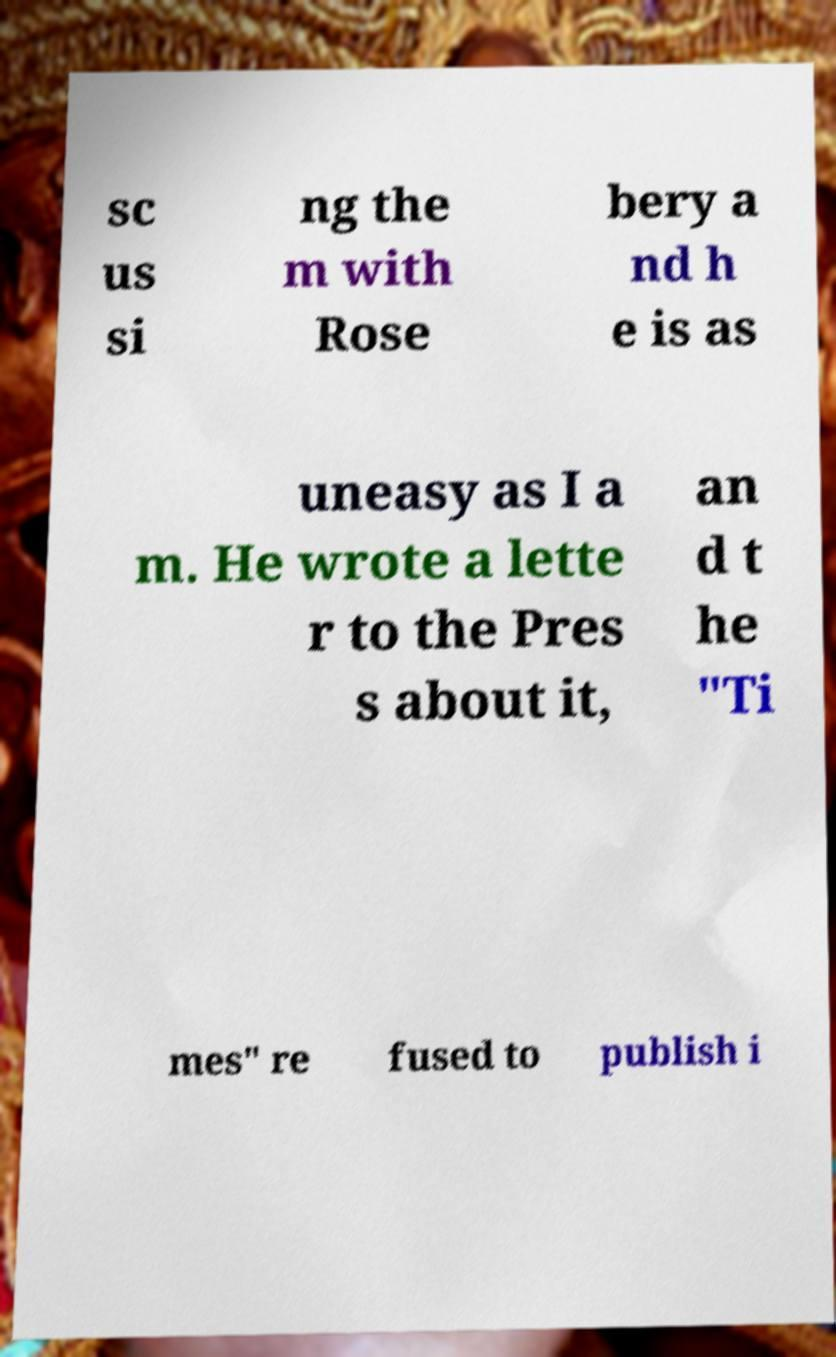There's text embedded in this image that I need extracted. Can you transcribe it verbatim? sc us si ng the m with Rose bery a nd h e is as uneasy as I a m. He wrote a lette r to the Pres s about it, an d t he "Ti mes" re fused to publish i 